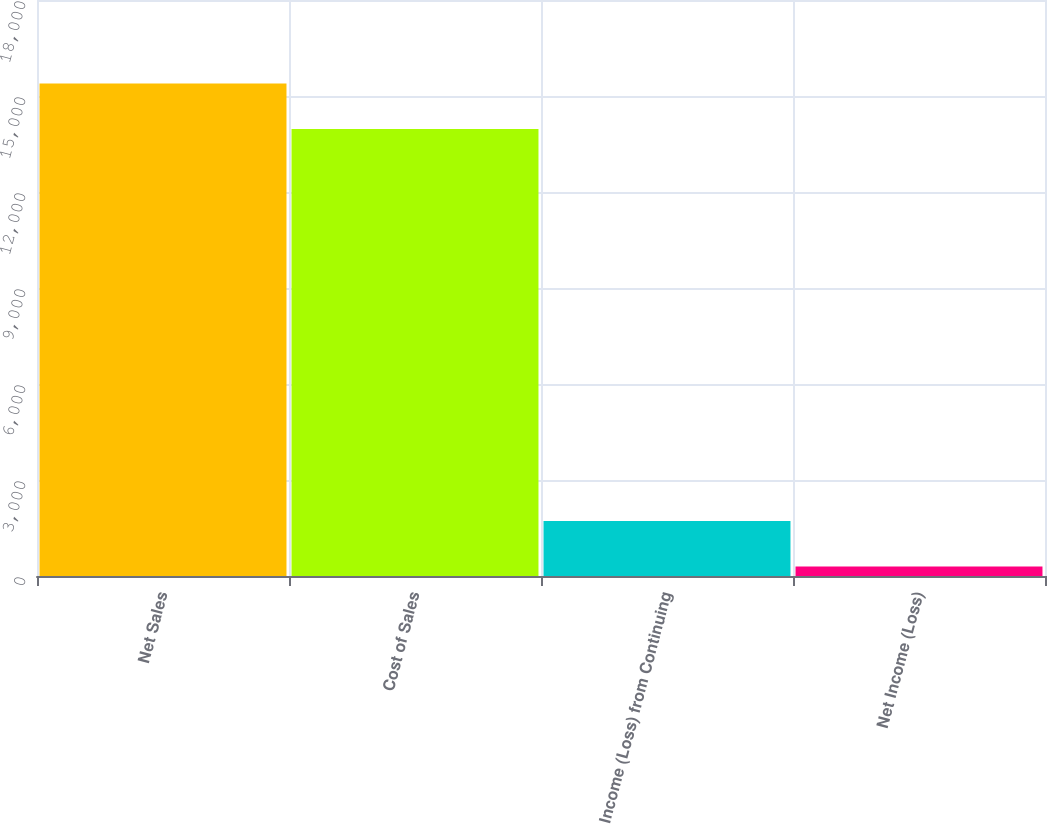Convert chart to OTSL. <chart><loc_0><loc_0><loc_500><loc_500><bar_chart><fcel>Net Sales<fcel>Cost of Sales<fcel>Income (Loss) from Continuing<fcel>Net Income (Loss)<nl><fcel>15390.7<fcel>13970<fcel>1717.7<fcel>297<nl></chart> 